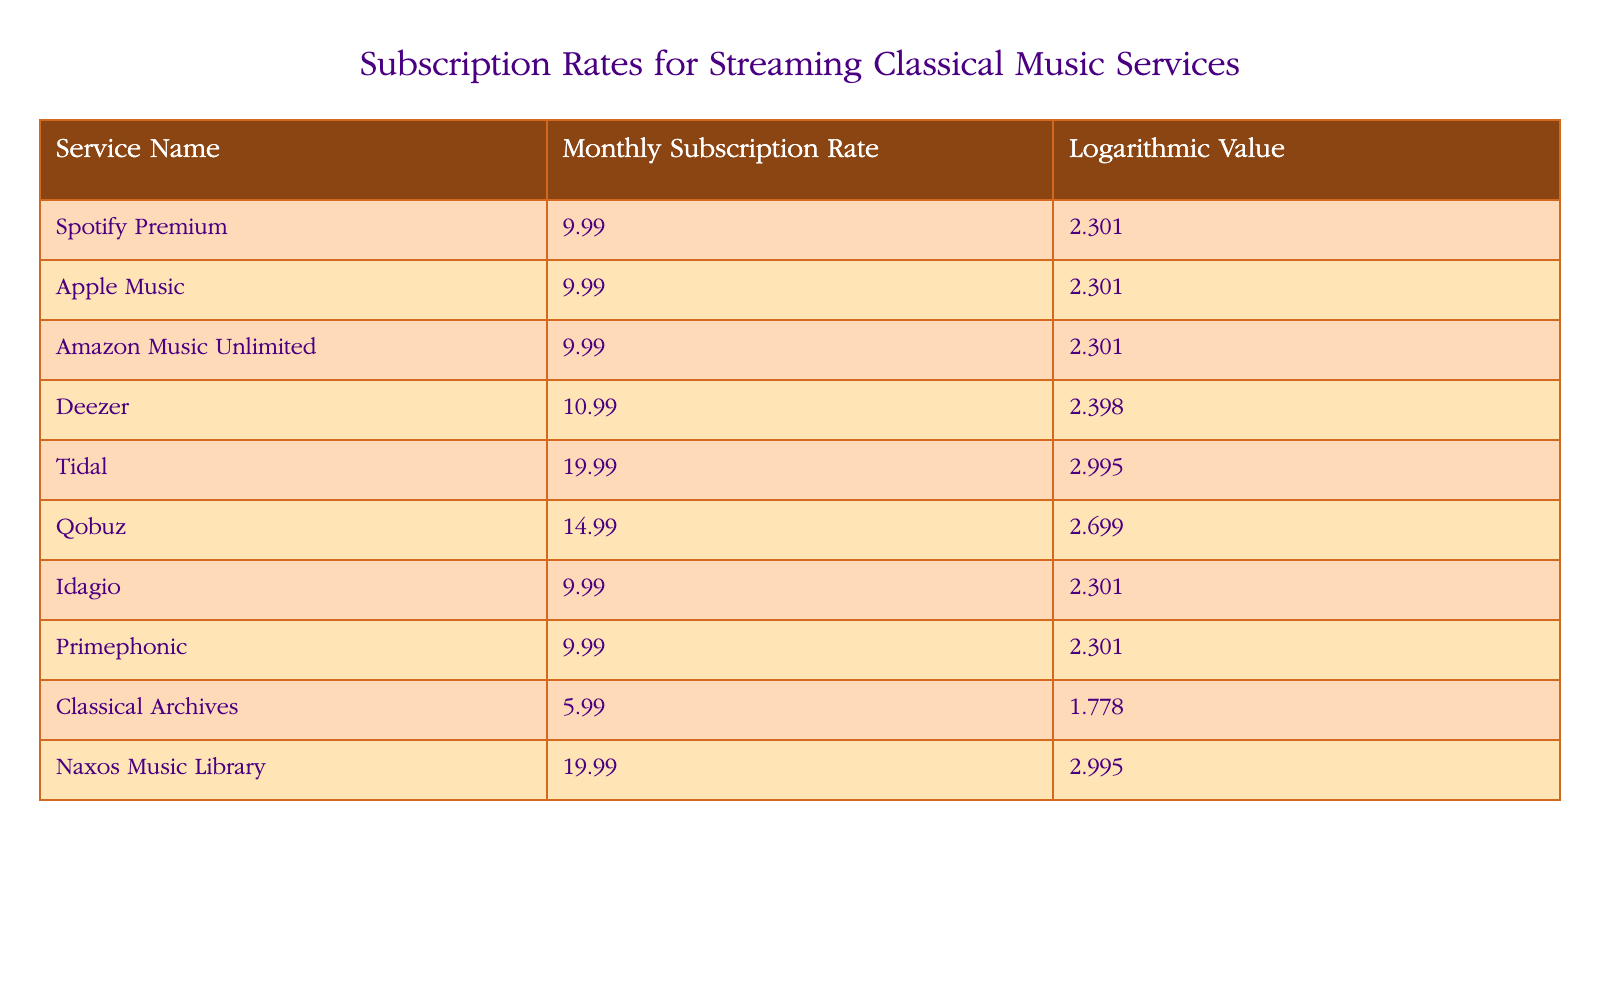What is the lowest monthly subscription rate among the services listed? According to the table, the service with the lowest monthly subscription rate is Classical Archives, which has a rate of 5.99.
Answer: 5.99 How many services have a subscription rate of 9.99? The table lists several services that have a subscription rate of 9.99: Spotify Premium, Apple Music, Idagio, and Primephonic, totaling four services.
Answer: 4 What is the average subscription rate of all the listed services? To find the average subscription rate, we sum all the rates: 9.99 + 9.99 + 9.99 + 10.99 + 19.99 + 14.99 + 9.99 + 9.99 + 5.99 + 19.99 =  119.9. Then, divide by the number of services, which is 10: 119.9 / 10 = 11.99.
Answer: 11.99 Which service has the highest logarithmic value, and what is that value? According to the table, both Tidal and Naxos Music Library have the highest logarithmic value of 2.995.
Answer: Tidal and Naxos Music Library, 2.995 Is the subscription rate of Deezer higher than that of Primephonic? In the table, Deezer's subscription rate is 10.99, while Primephonic's rate is 9.99, which means Deezer does have a higher rate than Primephonic.
Answer: Yes What is the difference in subscription rates between Qobuz and the lowest priced service? Qobuz's subscription rate is 14.99, and the lowest priced service, Classical Archives, has a rate of 5.99. The difference is 14.99 - 5.99 = 9.00.
Answer: 9.00 How many services cost 19.99 or more? According to the table, Tidal and Naxos Music Library both have subscription rates of 19.99, which means there are 2 services with a rate of 19.99 or more.
Answer: 2 Which services have the same logarithmic value of 2.301? The services that share the logarithmic value of 2.301 are Spotify Premium, Apple Music, Idagio, and Primephonic, totaling four services.
Answer: 4 What percentage of the services have a subscription rate below 10.00? The services with a subscription rate below 10.00 are Classical Archives, and the four services with a rate of 9.99, which makes for a total of 5 services. The percentage is (5/10)*100 = 50%.
Answer: 50% 